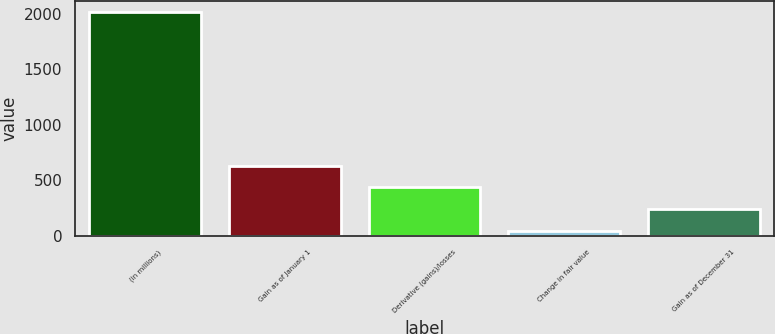Convert chart to OTSL. <chart><loc_0><loc_0><loc_500><loc_500><bar_chart><fcel>(in millions)<fcel>Gain as of January 1<fcel>Derivative (gains)/losses<fcel>Change in fair value<fcel>Gain as of December 31<nl><fcel>2015<fcel>631.1<fcel>433.4<fcel>38<fcel>235.7<nl></chart> 